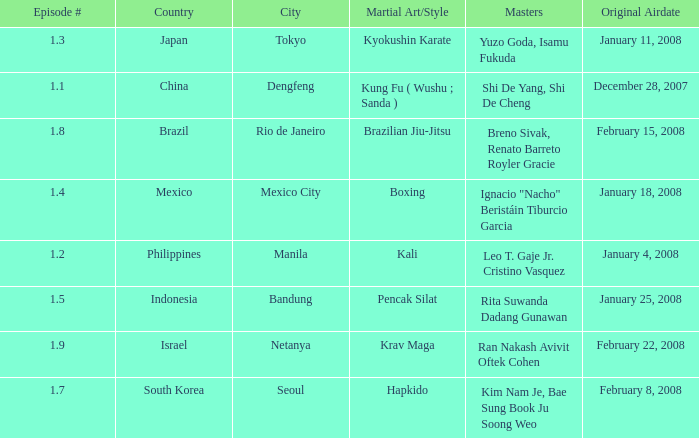Which masters fought in hapkido style? Kim Nam Je, Bae Sung Book Ju Soong Weo. 